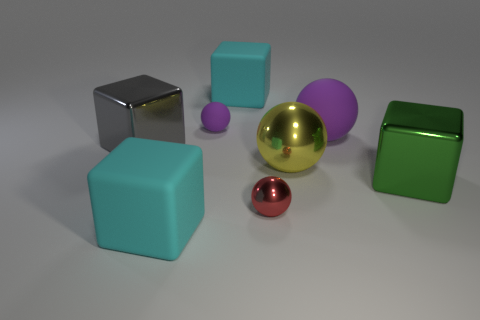The gray object that is the same shape as the big green thing is what size?
Your answer should be compact. Large. What is the color of the other tiny metal thing that is the same shape as the tiny purple thing?
Provide a short and direct response. Red. What number of large purple spheres have the same material as the large gray cube?
Offer a very short reply. 0. There is a metal cube that is right of the gray metallic object; does it have the same size as the red thing?
Your answer should be very brief. No. The matte ball that is the same size as the yellow shiny sphere is what color?
Offer a terse response. Purple. How many red spheres are behind the small matte thing?
Your response must be concise. 0. Are there any yellow shiny objects?
Make the answer very short. Yes. There is a object left of the matte object in front of the large metal block on the left side of the tiny red thing; how big is it?
Provide a short and direct response. Large. What number of other things are the same size as the yellow object?
Offer a very short reply. 5. What size is the block in front of the small shiny ball?
Provide a short and direct response. Large. 